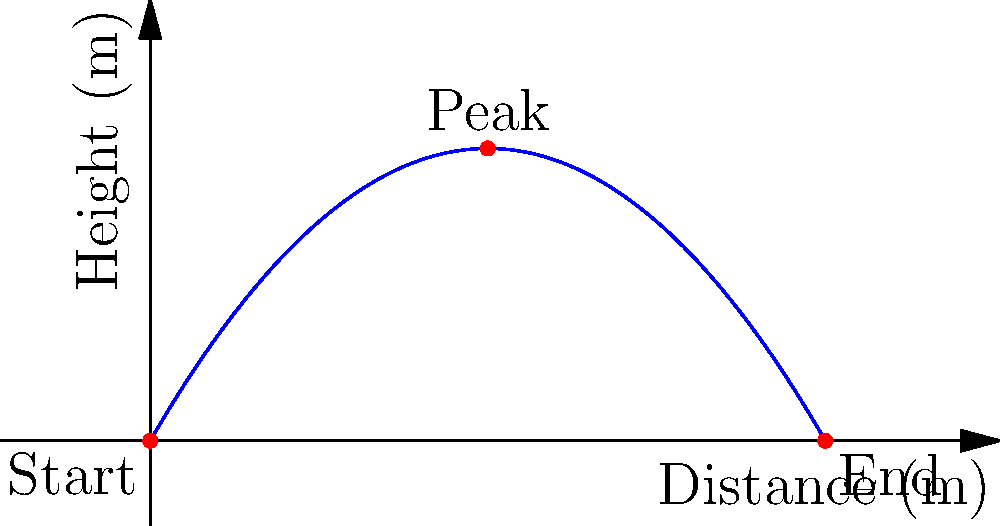A basketball player shoots a ball with an initial velocity of 15 m/s at an angle of 60° above the horizontal. Calculate:
a) The maximum height reached by the ball
b) The total time the ball is in the air
c) The horizontal distance traveled by the ball

Assume air resistance is negligible and use g = 9.8 m/s². Let's solve this step-by-step using the equations of motion for projectile motion.

Given:
Initial velocity, $v_0 = 15$ m/s
Angle, $\theta = 60°$
Acceleration due to gravity, $g = 9.8$ m/s²

Step 1: Decompose the initial velocity into horizontal and vertical components.
$v_{0x} = v_0 \cos(\theta) = 15 \cos(60°) = 7.5$ m/s
$v_{0y} = v_0 \sin(\theta) = 15 \sin(60°) = 13.0$ m/s

a) Maximum height:
The maximum height is reached when the vertical velocity becomes zero.
$v_y = v_{0y} - gt$
At the highest point, $v_y = 0$
$0 = 13.0 - 9.8t$
$t = 1.33$ s (time to reach maximum height)

Now, use the equation: $y = v_{0y}t - \frac{1}{2}gt^2$
$y_{max} = 13.0(1.33) - \frac{1}{2}(9.8)(1.33)^2 = 8.66$ m

b) Total time in the air:
The total time is twice the time to reach maximum height.
$t_{total} = 2(1.33) = 2.66$ s

c) Horizontal distance:
Use the equation: $x = v_{0x}t$
$x = 7.5(2.66) = 19.95$ m
Answer: a) 8.66 m
b) 2.66 s
c) 19.95 m 